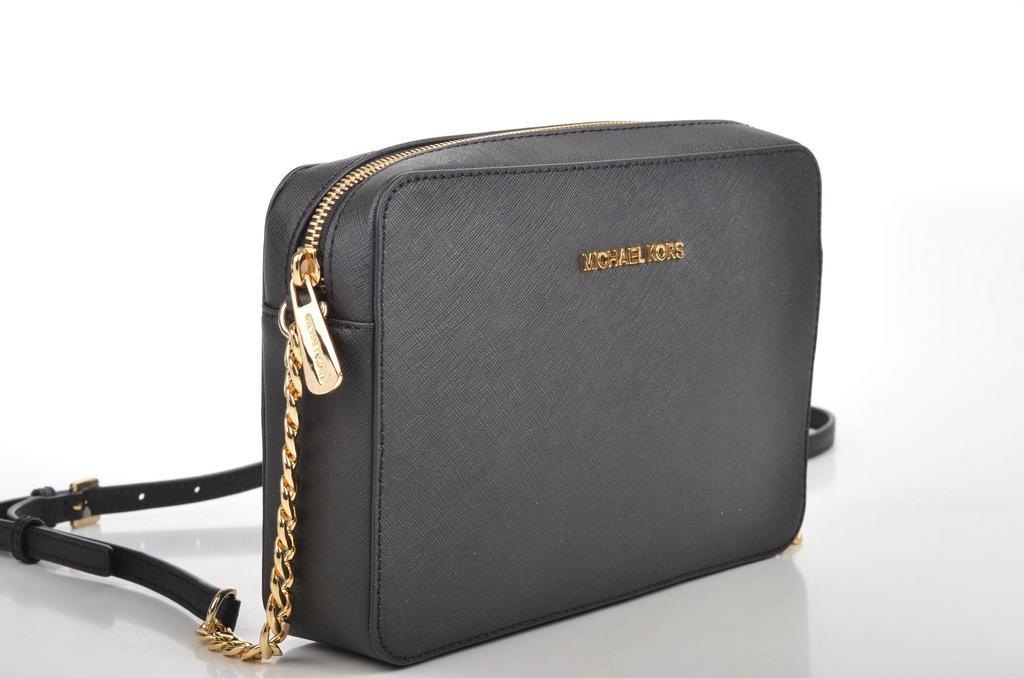Could you give a brief overview of what you see in this image? This is bag. 